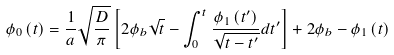Convert formula to latex. <formula><loc_0><loc_0><loc_500><loc_500>\phi _ { 0 } \left ( t \right ) = \frac { 1 } { a } \sqrt { \frac { D } { \pi } } \left [ 2 \phi _ { b } \sqrt { t } - \int _ { 0 } ^ { t } \frac { \phi _ { 1 } \left ( t ^ { \prime } \right ) } { \sqrt { t - t ^ { \prime } } } d t ^ { \prime } \right ] + 2 \phi _ { b } - \phi _ { 1 } \left ( t \right )</formula> 